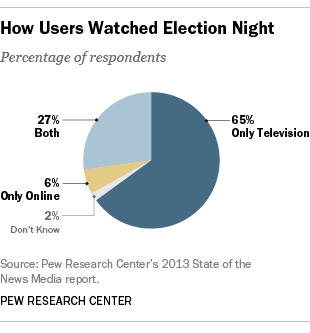Draw attention to some important aspects in this diagram. The ratio of the smallest segment and the second largest segment is 0.07407... The color of the 65% segment is blue, and it is correct to say that it is. 